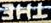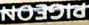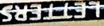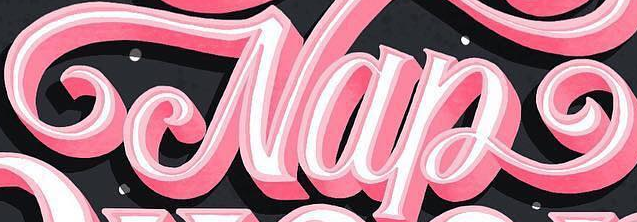Transcribe the words shown in these images in order, separated by a semicolon. THE; PIGEON; LETTERS; Nap 